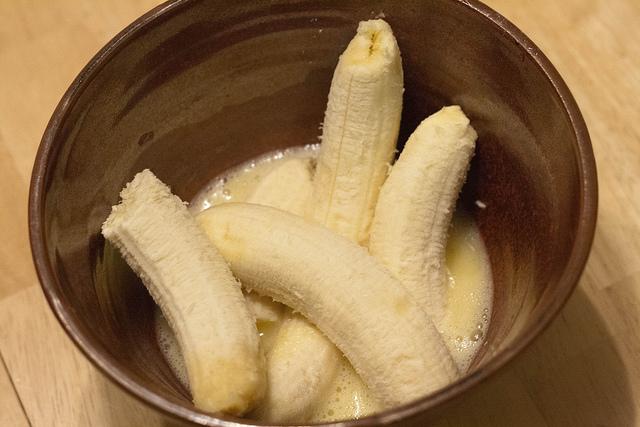Is this picture from indoors or outdoors?
Keep it brief. Indoors. What is the liquid with the bananas?
Short answer required. Milk. What type of fruit is in the bowl?
Be succinct. Bananas. 